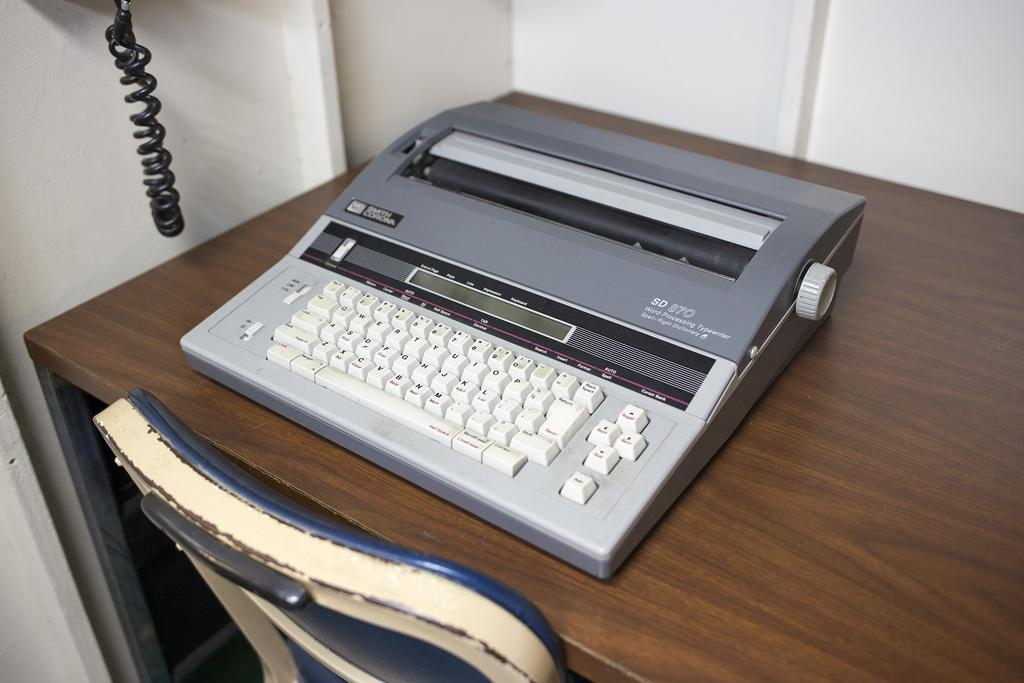Provide a one-sentence caption for the provided image. An SD 870 Word Processing Typewriter sits on a desk. 